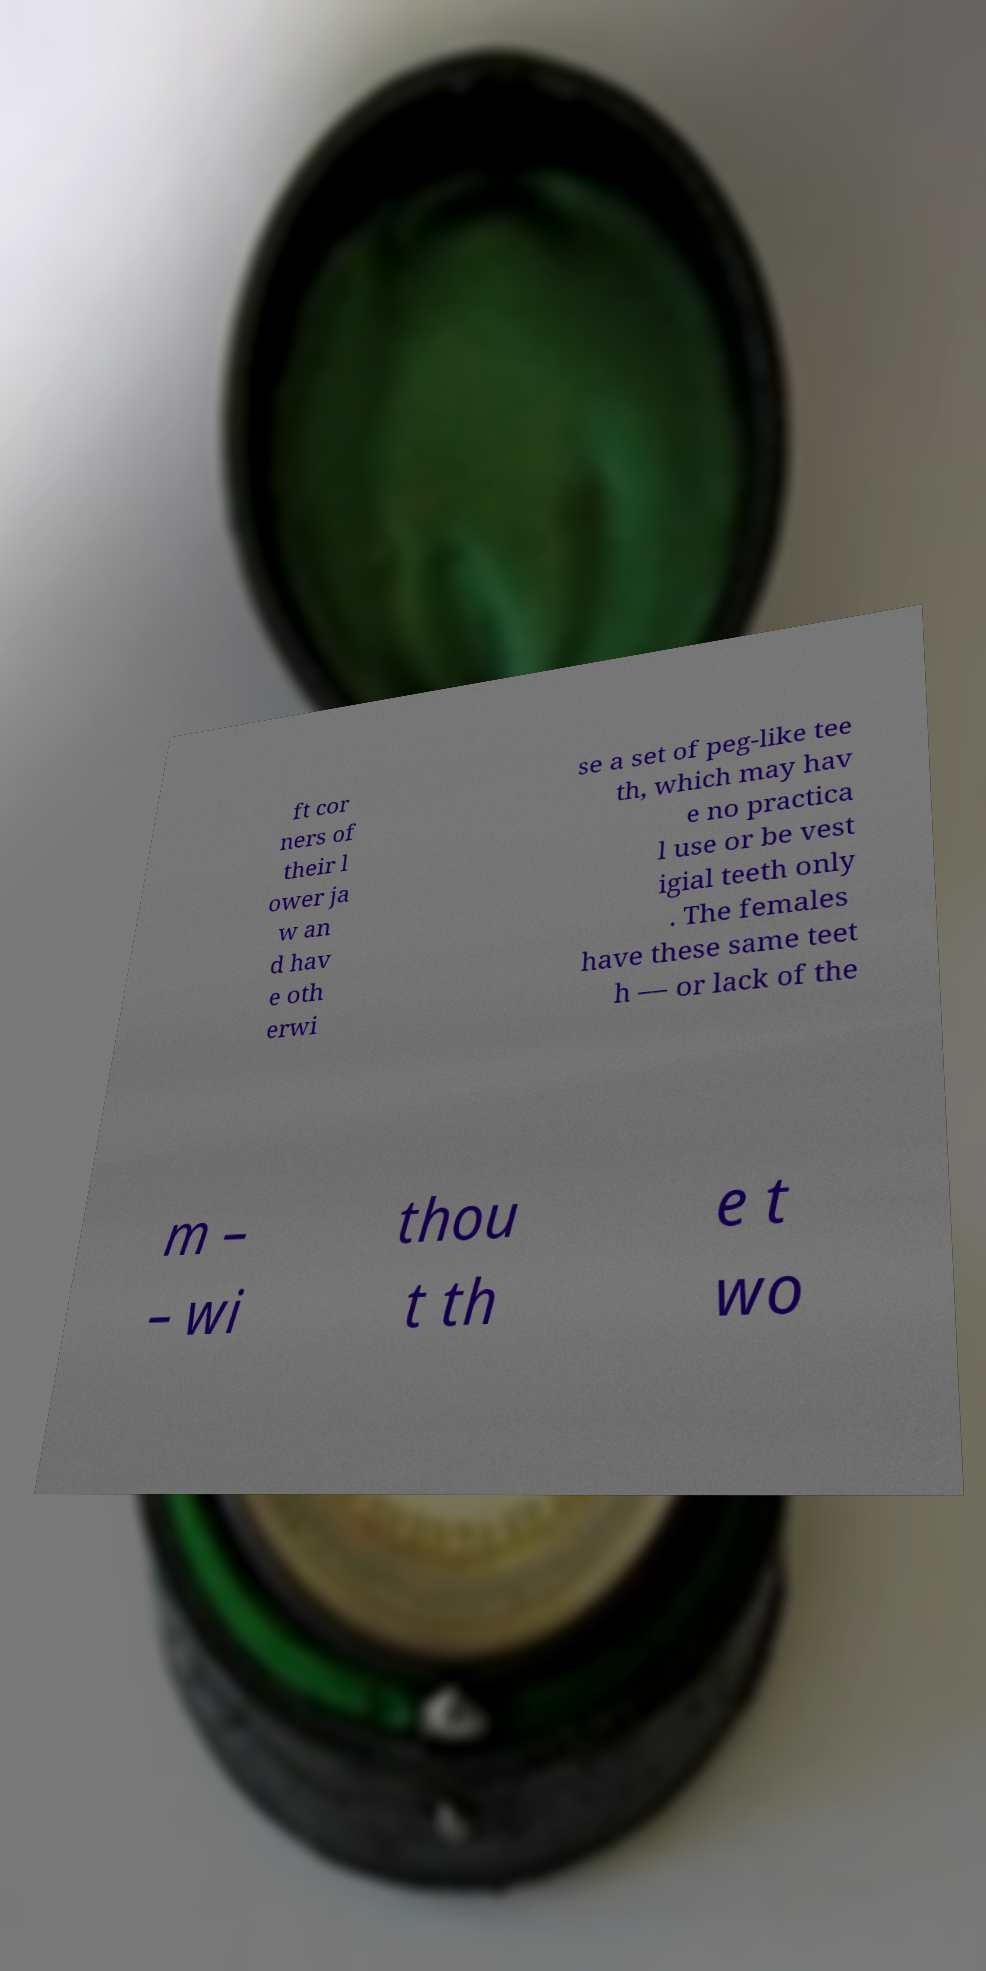What messages or text are displayed in this image? I need them in a readable, typed format. ft cor ners of their l ower ja w an d hav e oth erwi se a set of peg-like tee th, which may hav e no practica l use or be vest igial teeth only . The females have these same teet h –– or lack of the m – – wi thou t th e t wo 